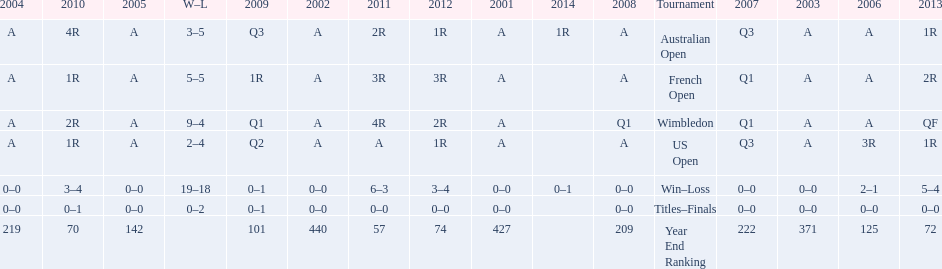What was the total number of matches played from 2001 to 2014? 37. 